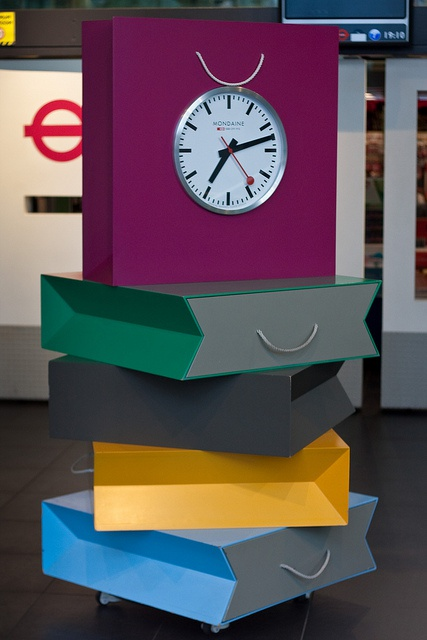Describe the objects in this image and their specific colors. I can see a clock in black, lightblue, and gray tones in this image. 